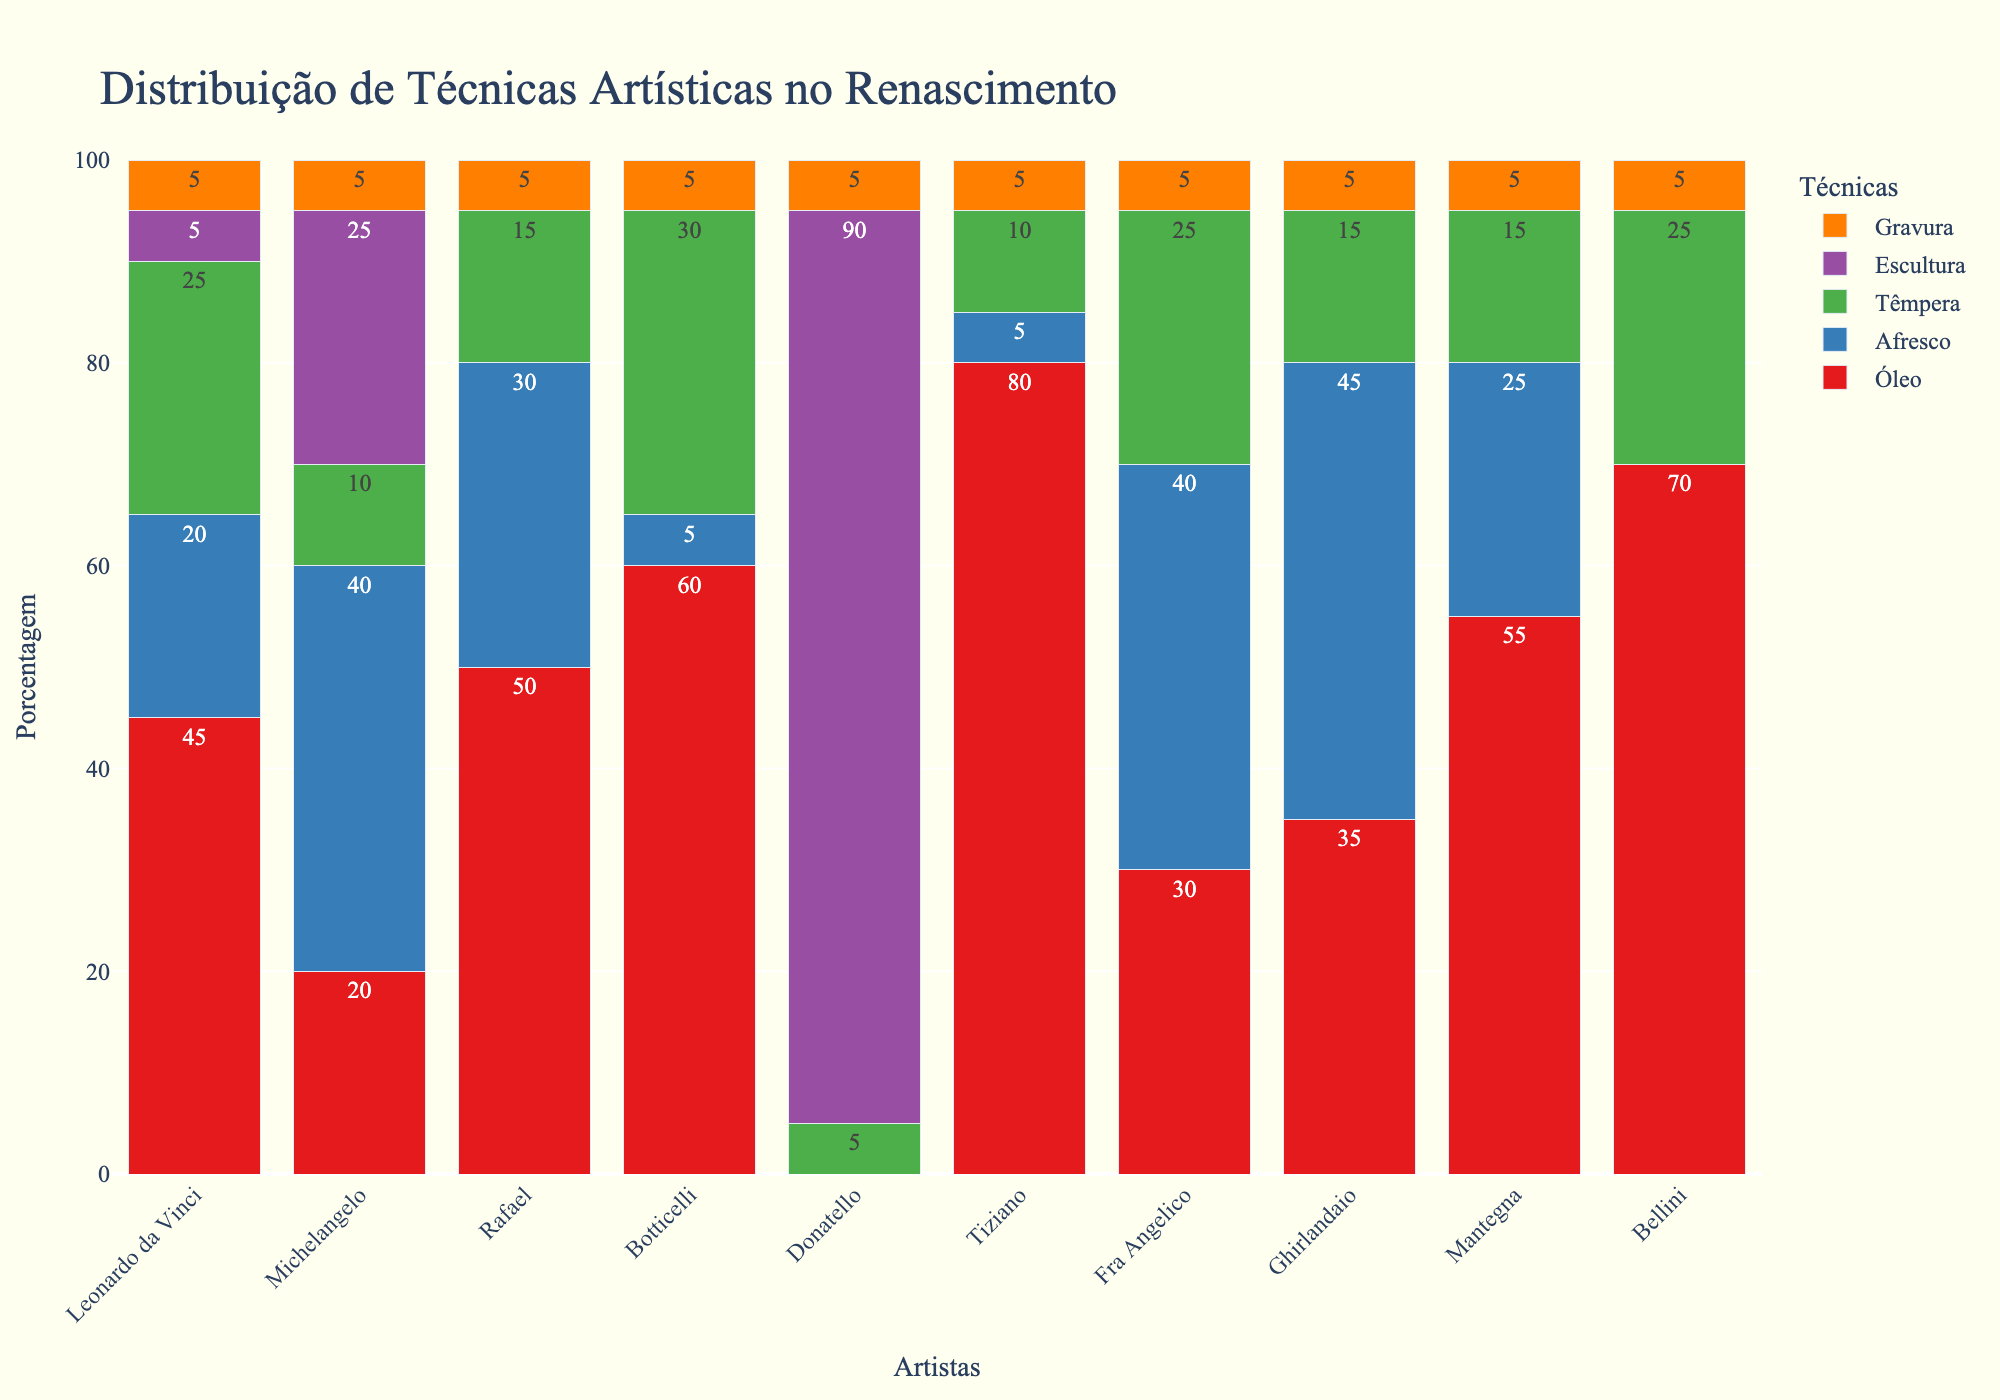Qual artista usou mais a técnica de óleo? A barra mais alta de óleo é a vermelha, que corresponde ao Tiziano. A porcentagem de óleo usada por Tiziano é 80, a mais alta entre todos os artistas.
Answer: Tiziano Quais dois artistas têm a maior diferença na porcentagem de uso de afresco? Tiziano e Donatello não usaram a técnica de afresco. A maior diferença entre os artistas que usaram afresco é de Fra Angelico e Michelangelo. Fra Angelico e Ghirlandaio têm 40 e 45, respectivamente. Michelangelo tem 40, então a maior diferença de porcentagem de uso de afresco é entre Ghirlandaio e Donatello, que é de 45.
Answer: Michelangelo e Ghirlandaio Que técnica artística Leonardo da Vinci usou menos? Observando as barras da Vinci, a técnica com a menor altura é escultura e gravura, cada uma com uma porcentagem de 5.
Answer: Escultura e gravura Quem usou mais a técnica de escultura? Observando a altura das barras roxas, Donatello tem a barra mais alta com uma porcentagem de 90.
Answer: Donatello Qual artista usou mais técnicas de pinturas (óleo, afresco, têmpera) combinadas? Vamos somar as porcentagens de óleo, afresco e têmpera para cada artista. 
Leonardo da Vinci: 45 + 20 + 25 = 90
Michelangelo: 20 + 40 + 10 = 70
Rafael: 50 + 30 + 15 = 95
Botticelli: 60 + 5 + 30 = 95
Donatello: 0 + 0 + 5 = 5
Tiziano: 80 + 5 + 10 = 95
Fra Angelico: 30 + 40 + 25 = 95
Ghirlandaio: 35 + 45 + 15 = 95
Mantegna: 55 + 25 + 15 = 95
Bellini: 70 + 0 + 25 = 95
Os artistas que usaram mais combinações de técnicas de pinturas são Rafael, Botticelli, Tiziano, Fra Angelico, Ghirlandaio, Mantegna, e Bellini, com 95%.
Answer: Rafael, Botticelli, Tiziano, Fra Angelico, Ghirlandaio, Mantegna, Bellini Qual técnica foi predominantemente usada por Botticelli? Observando as barras de Botticelli, a técnica com a maior altura é a barra vermelha (óleo) com 60%
Answer: Óleo Entre Michelangelo e Leonardo da Vinci, quem usou mais a técnica de têmpera? Observando as barras verdes, Leonardo da Vinci usou 25% e Michelangelo usou 10%. Leonardo da Vinci usou mais têmpera.
Answer: Leonardo da Vinci Quais técnicas não foram usadas por Donatello? Observando as barras em Donatello, ele não possui barras para óleo, afresco, nem temos barra de afresco, óleo ou têmpera.
Answer: Óleo, Afresco, Têmpera 